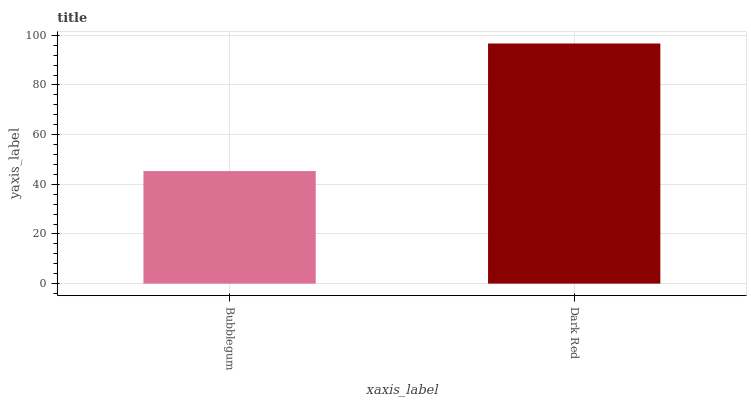Is Dark Red the minimum?
Answer yes or no. No. Is Dark Red greater than Bubblegum?
Answer yes or no. Yes. Is Bubblegum less than Dark Red?
Answer yes or no. Yes. Is Bubblegum greater than Dark Red?
Answer yes or no. No. Is Dark Red less than Bubblegum?
Answer yes or no. No. Is Dark Red the high median?
Answer yes or no. Yes. Is Bubblegum the low median?
Answer yes or no. Yes. Is Bubblegum the high median?
Answer yes or no. No. Is Dark Red the low median?
Answer yes or no. No. 